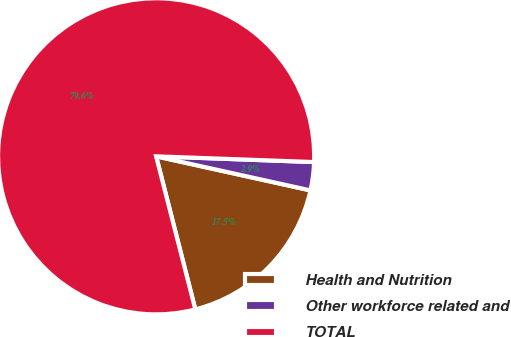<chart> <loc_0><loc_0><loc_500><loc_500><pie_chart><fcel>Health and Nutrition<fcel>Other workforce related and<fcel>TOTAL<nl><fcel>17.55%<fcel>2.88%<fcel>79.57%<nl></chart> 